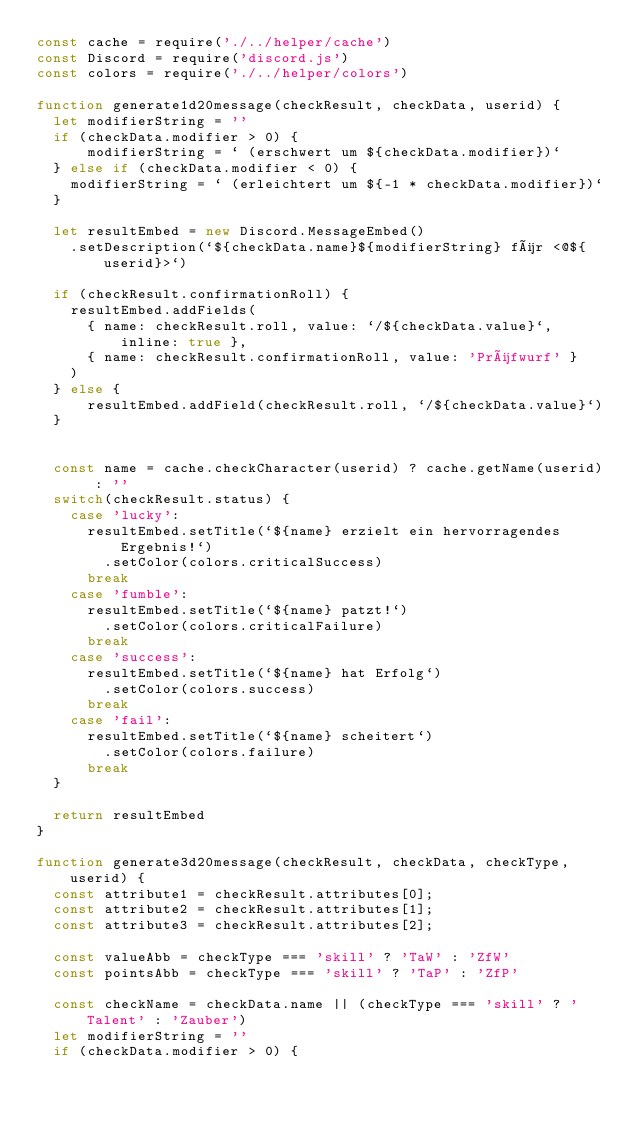<code> <loc_0><loc_0><loc_500><loc_500><_JavaScript_>const cache = require('./../helper/cache')
const Discord = require('discord.js')
const colors = require('./../helper/colors')

function generate1d20message(checkResult, checkData, userid) {
  let modifierString = ''
  if (checkData.modifier > 0) {
      modifierString = ` (erschwert um ${checkData.modifier})`
  } else if (checkData.modifier < 0) {
    modifierString = ` (erleichtert um ${-1 * checkData.modifier})`
  }

  let resultEmbed = new Discord.MessageEmbed()
    .setDescription(`${checkData.name}${modifierString} für <@${userid}>`)

  if (checkResult.confirmationRoll) {
    resultEmbed.addFields(
      { name: checkResult.roll, value: `/${checkData.value}`, inline: true },
      { name: checkResult.confirmationRoll, value: 'Prüfwurf' }
    )
  } else {
      resultEmbed.addField(checkResult.roll, `/${checkData.value}`)
  }


  const name = cache.checkCharacter(userid) ? cache.getName(userid) : ''
  switch(checkResult.status) {
    case 'lucky':
      resultEmbed.setTitle(`${name} erzielt ein hervorragendes Ergebnis!`)
        .setColor(colors.criticalSuccess)
      break
    case 'fumble':
      resultEmbed.setTitle(`${name} patzt!`)
        .setColor(colors.criticalFailure)
      break
    case 'success':
      resultEmbed.setTitle(`${name} hat Erfolg`)
        .setColor(colors.success)
      break
    case 'fail':
      resultEmbed.setTitle(`${name} scheitert`)
        .setColor(colors.failure)
      break
  }

  return resultEmbed
}

function generate3d20message(checkResult, checkData, checkType, userid) {
  const attribute1 = checkResult.attributes[0];
  const attribute2 = checkResult.attributes[1];
  const attribute3 = checkResult.attributes[2];

  const valueAbb = checkType === 'skill' ? 'TaW' : 'ZfW'
  const pointsAbb = checkType === 'skill' ? 'TaP' : 'ZfP'

  const checkName = checkData.name || (checkType === 'skill' ? 'Talent' : 'Zauber')
  let modifierString = ''
  if (checkData.modifier > 0) {</code> 